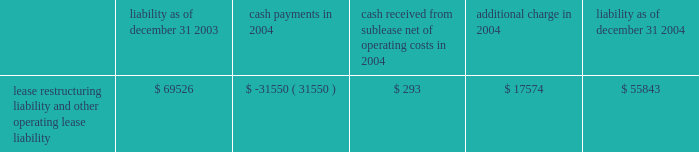The activity related to the restructuring liability for 2004 is as follows ( in thousands ) : non-operating items interest income increased $ 1.7 million to $ 12.0 million in 2005 from $ 10.3 million in 2004 .
The increase was mainly the result of higher returns on invested funds .
Interest expense decreased $ 1.0 million , or 5% ( 5 % ) , to $ 17.3 million in 2005 from $ 18.3 million in 2004 as a result of the exchange of newly issued stock for a portion of our outstanding convertible debt in the second half of 2005 .
In addition , as a result of the issuance during 2005 of common stock in exchange for convertible subordinated notes , we recorded a non- cash charge of $ 48.2 million .
This charge related to the incremental shares issued in the transactions over the number of shares that would have been issued upon the conversion of the notes under their original terms .
Liquidity and capital resources we have incurred operating losses since our inception and historically have financed our operations principally through public and private offerings of our equity and debt securities , strategic collaborative agreements that include research and/or development funding , development milestones and royalties on the sales of products , investment income and proceeds from the issuance of stock under our employee benefit programs .
At december 31 , 2006 , we had cash , cash equivalents and marketable securities of $ 761.8 million , which was an increase of $ 354.2 million from $ 407.5 million at december 31 , 2005 .
The increase was primarily a result of : 2022 $ 313.7 million in net proceeds from our september 2006 public offering of common stock ; 2022 $ 165.0 million from an up-front payment we received in connection with signing the janssen agreement ; 2022 $ 52.4 million from the issuance of common stock under our employee benefit plans ; and 2022 $ 30.0 million from the sale of shares of altus pharmaceuticals inc .
Common stock and warrants to purchase altus common stock .
These cash inflows were partially offset by the significant cash expenditures we made in 2006 related to research and development expenses and sales , general and administrative expenses .
Capital expenditures for property and equipment during 2006 were $ 32.4 million .
At december 31 , 2006 , we had $ 42.1 million in aggregate principal amount of the 2007 notes and $ 59.6 million in aggregate principal amount of the 2011 notes outstanding .
The 2007 notes are due in september 2007 and are convertible into common stock at the option of the holder at a price equal to $ 92.26 per share , subject to adjustment under certain circumstances .
In february 2007 , we announced that we will redeem our 2011 notes on march 5 , 2007 .
The 2011 notes are convertible into shares of our common stock at the option of the holder at a price equal to $ 14.94 per share .
We expect the holders of the 2011 notes will elect to convert their notes into stock , in which case we will issue approximately 4.0 million .
We will be required to repay any 2011 notes that are not converted at the rate of $ 1003.19 per $ 1000 principal amount , which includes principal and interest that will accrue to the redemption date .
Liability as of december 31 , payments in 2004 cash received from sublease , net of operating costs in 2004 additional charge in liability as of december 31 , lease restructuring liability and other operating lease liability $ 69526 $ ( 31550 ) $ 293 $ 17574 $ 55843 .
The activity related to the restructuring liability for 2004 is as follows ( in thousands ) : non-operating items interest income increased $ 1.7 million to $ 12.0 million in 2005 from $ 10.3 million in 2004 .
The increase was mainly the result of higher returns on invested funds .
Interest expense decreased $ 1.0 million , or 5% ( 5 % ) , to $ 17.3 million in 2005 from $ 18.3 million in 2004 as a result of the exchange of newly issued stock for a portion of our outstanding convertible debt in the second half of 2005 .
In addition , as a result of the issuance during 2005 of common stock in exchange for convertible subordinated notes , we recorded a non- cash charge of $ 48.2 million .
This charge related to the incremental shares issued in the transactions over the number of shares that would have been issued upon the conversion of the notes under their original terms .
Liquidity and capital resources we have incurred operating losses since our inception and historically have financed our operations principally through public and private offerings of our equity and debt securities , strategic collaborative agreements that include research and/or development funding , development milestones and royalties on the sales of products , investment income and proceeds from the issuance of stock under our employee benefit programs .
At december 31 , 2006 , we had cash , cash equivalents and marketable securities of $ 761.8 million , which was an increase of $ 354.2 million from $ 407.5 million at december 31 , 2005 .
The increase was primarily a result of : 2022 $ 313.7 million in net proceeds from our september 2006 public offering of common stock ; 2022 $ 165.0 million from an up-front payment we received in connection with signing the janssen agreement ; 2022 $ 52.4 million from the issuance of common stock under our employee benefit plans ; and 2022 $ 30.0 million from the sale of shares of altus pharmaceuticals inc .
Common stock and warrants to purchase altus common stock .
These cash inflows were partially offset by the significant cash expenditures we made in 2006 related to research and development expenses and sales , general and administrative expenses .
Capital expenditures for property and equipment during 2006 were $ 32.4 million .
At december 31 , 2006 , we had $ 42.1 million in aggregate principal amount of the 2007 notes and $ 59.6 million in aggregate principal amount of the 2011 notes outstanding .
The 2007 notes are due in september 2007 and are convertible into common stock at the option of the holder at a price equal to $ 92.26 per share , subject to adjustment under certain circumstances .
In february 2007 , we announced that we will redeem our 2011 notes on march 5 , 2007 .
The 2011 notes are convertible into shares of our common stock at the option of the holder at a price equal to $ 14.94 per share .
We expect the holders of the 2011 notes will elect to convert their notes into stock , in which case we will issue approximately 4.0 million .
We will be required to repay any 2011 notes that are not converted at the rate of $ 1003.19 per $ 1000 principal amount , which includes principal and interest that will accrue to the redemption date .
Liability as of december 31 , payments in 2004 cash received from sublease , net of operating costs in 2004 additional charge in liability as of december 31 , lease restructuring liability and other operating lease liability $ 69526 $ ( 31550 ) $ 293 $ 17574 $ 55843 .
What is the percent of the in the non operating income associated with interest income in 2005? 
Computations: (1.7 / 10.3)
Answer: 0.16505. 